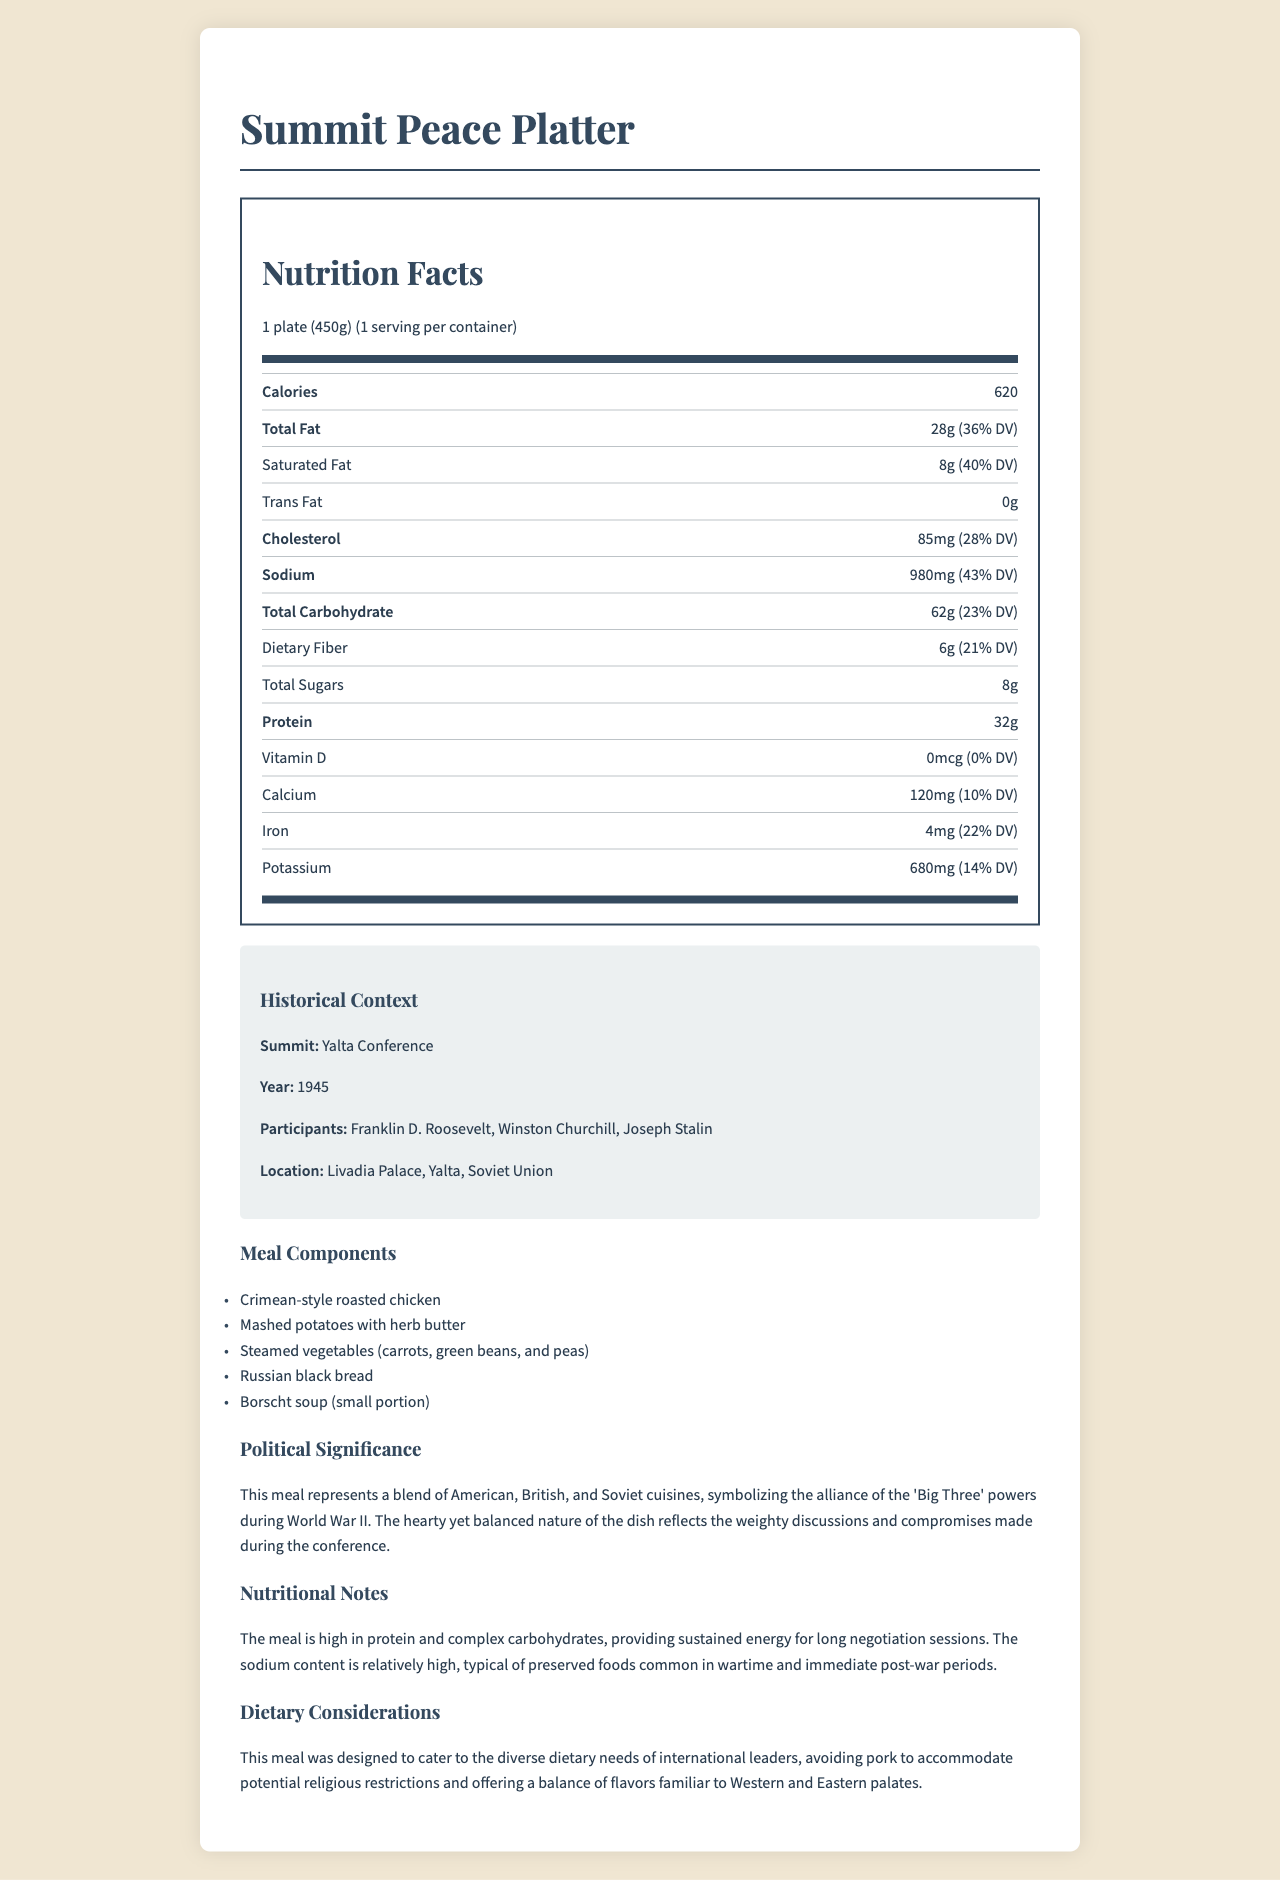what is the serving size? The serving size is specified at the beginning of the Nutrition Facts part of the document.
Answer: 1 plate (450g) how many calories are in a serving of the meal? The calorie count is provided in the Nutrition Facts section as 620 calories per serving.
Answer: 620 what is the percentage of the daily value of total fat in this meal? The percentage daily value for total fat is mentioned alongside the total fat amount (28g) as 36%.
Answer: 36% who were the participants at the Yalta Conference? The historical context section lists the participants of the Yalta Conference as Franklin D. Roosevelt, Winston Churchill, and Joseph Stalin.
Answer: Franklin D. Roosevelt, Winston Churchill, Joseph Stalin which component of the meal is specifically mentioned to be avoided to accommodate religious restrictions? The dietary considerations section mentions that the meal was designed to avoid pork to accommodate potential religious restrictions.
Answer: Pork what is the total carbohydrate content in the Summit Peace Platter? The total carbohydrate content is listed in the Nutrition Facts as 62g.
Answer: 62g how much dietary fiber does the meal contain? The dietary fiber content is given as 6g in the Nutrition Facts section.
Answer: 6g which nutrient has no daily value percentage? A. Dietary Fiber B. Protein C. Calcium D. Vitamin D The Nutrition Facts section lists Vitamin D with 0 micrograms and 0% daily value, indicating it has no daily value percentage.
Answer: D. Vitamin D what is the main idea of the document? The document includes sections on nutritional facts, historical context, meal components, political significance, nutritional notes, and dietary considerations, creating an overall picture of the meal and its importance.
Answer: The document provides a detailed description of the nutritional content, historical context, and political significance of the Summit Peace Platter meal served at the Yalta Conference. how is the sodium content in this meal described in the nutritional notes? The nutritional notes state that the sodium content is relatively high, typical of preserved foods common in wartime and immediate post-war periods.
Answer: Relatively high what percentage of the daily value does the cholesterol amount in the meal constitute? The Nutrition Facts section lists cholesterol as 85mg, which is 28% of the daily value.
Answer: 28% what food item is part of the meal and is also a traditional Russian dish? The meal components list Borscht soup, which is a traditional Russian dish.
Answer: Borscht soup which of the following leaders did not participate in the Yalta Conference? A. Harry S. Truman B. Winston Churchill C. Joseph Stalin D. Franklin D. Roosevelt The historical context lists Franklin D. Roosevelt, Winston Churchill, and Joseph Stalin as participants, but not Harry S. Truman.
Answer: A. Harry S. Truman did the meal include any dessert? The meal components list does not include any dessert items, only main course and side elements.
Answer: No were potatoes a part of the meal served at the Yalta Conference? The meal components list mentions "Mashed potatoes with herb butter" as part of the meal.
Answer: Yes how well does the energy profile of the meal support long negotiation sessions? The nutritional notes mention that the meal is high in protein and complex carbohydrates, offering sustained energy suitable for long negotiation sessions.
Answer: It provides sustained energy can it be determined which chef designed the meal? The document does not provide any details about the chef or the person who designed the meal.
Answer: Not enough information 